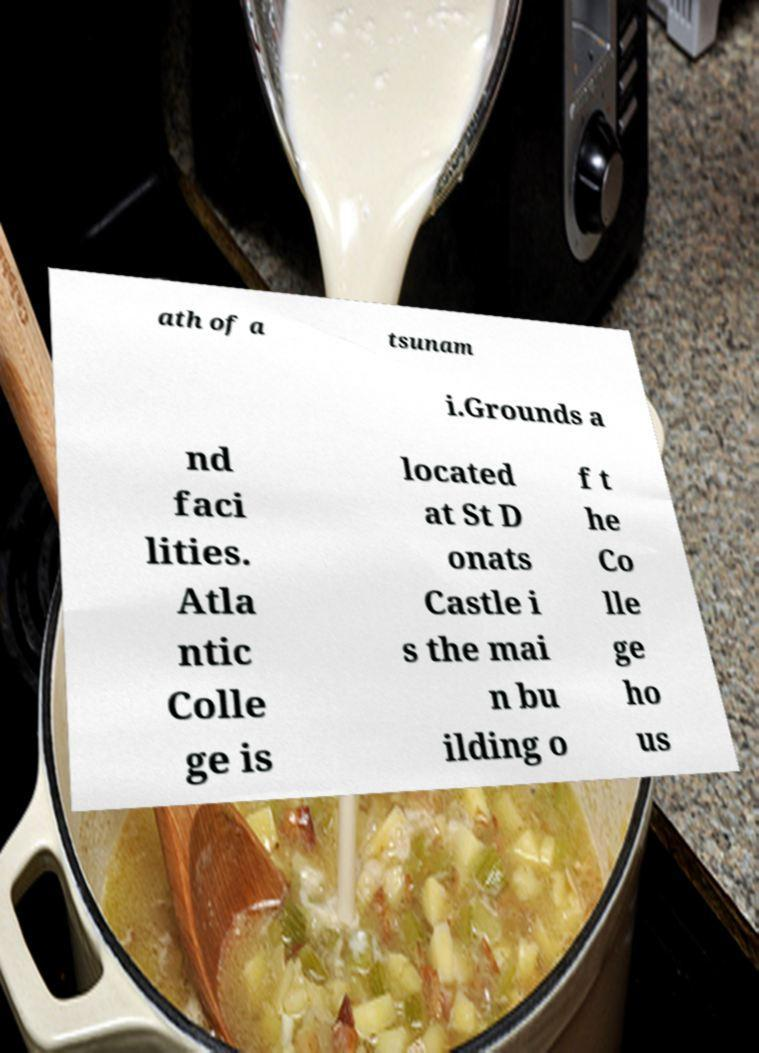Please identify and transcribe the text found in this image. ath of a tsunam i.Grounds a nd faci lities. Atla ntic Colle ge is located at St D onats Castle i s the mai n bu ilding o f t he Co lle ge ho us 